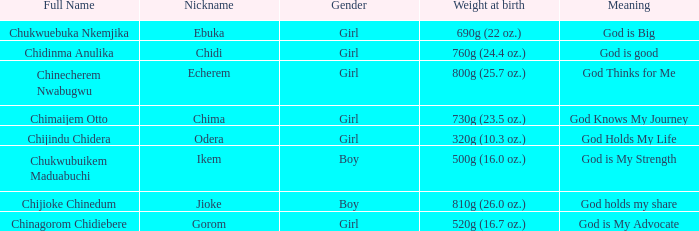What is the moniker of the boy who weighed 810g (2 Jioke. 